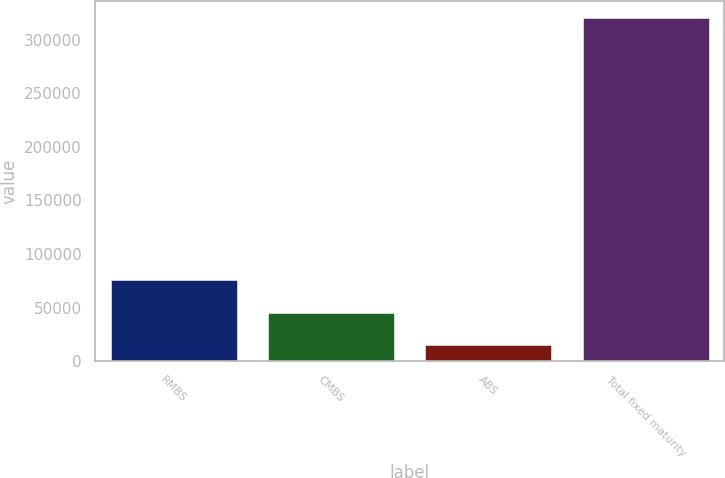Convert chart. <chart><loc_0><loc_0><loc_500><loc_500><bar_chart><fcel>RMBS<fcel>CMBS<fcel>ABS<fcel>Total fixed maturity<nl><fcel>75781.6<fcel>45253.3<fcel>14725<fcel>320008<nl></chart> 